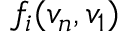Convert formula to latex. <formula><loc_0><loc_0><loc_500><loc_500>f _ { i } ( v _ { n } , v _ { 1 } )</formula> 